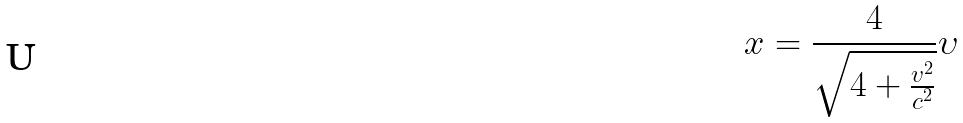Convert formula to latex. <formula><loc_0><loc_0><loc_500><loc_500>x = \frac { 4 } { \sqrt { 4 + \frac { v ^ { 2 } } { c ^ { 2 } } } } \upsilon</formula> 